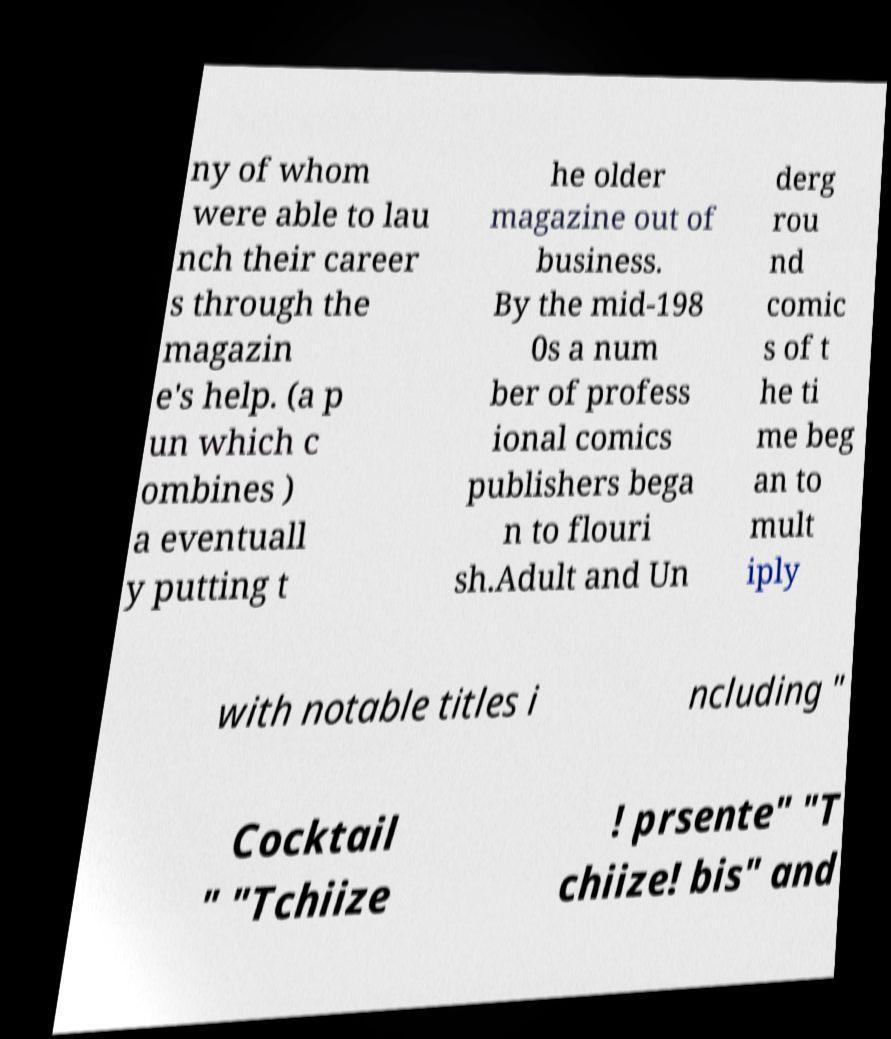I need the written content from this picture converted into text. Can you do that? ny of whom were able to lau nch their career s through the magazin e's help. (a p un which c ombines ) a eventuall y putting t he older magazine out of business. By the mid-198 0s a num ber of profess ional comics publishers bega n to flouri sh.Adult and Un derg rou nd comic s of t he ti me beg an to mult iply with notable titles i ncluding " Cocktail " "Tchiize ! prsente" "T chiize! bis" and 